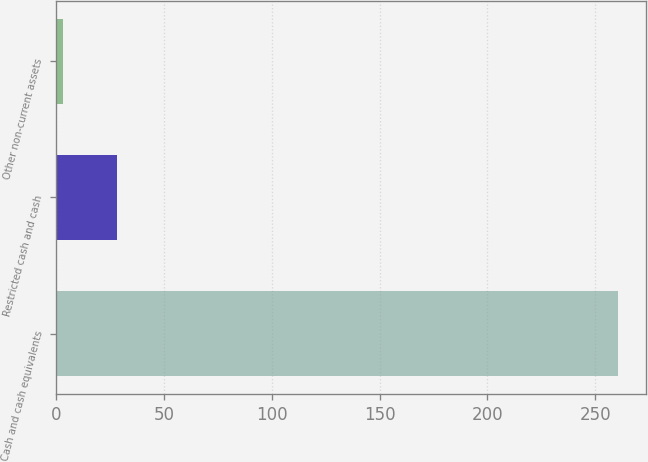<chart> <loc_0><loc_0><loc_500><loc_500><bar_chart><fcel>Cash and cash equivalents<fcel>Restricted cash and cash<fcel>Other non-current assets<nl><fcel>260.4<fcel>28.4<fcel>3<nl></chart> 